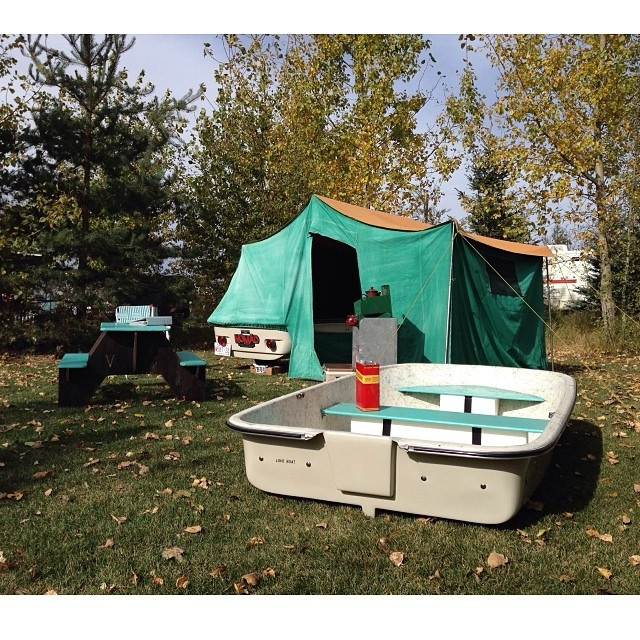Describe the objects in this image and their specific colors. I can see boat in white, tan, ivory, black, and darkgray tones, bench in white, black, teal, and gray tones, bench in white, turquoise, and darkgray tones, and dining table in white, teal, and black tones in this image. 